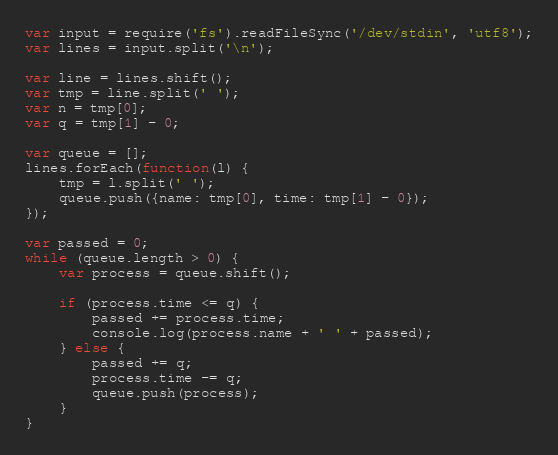<code> <loc_0><loc_0><loc_500><loc_500><_JavaScript_>var input = require('fs').readFileSync('/dev/stdin', 'utf8');
var lines = input.split('\n');

var line = lines.shift();
var tmp = line.split(' ');
var n = tmp[0];
var q = tmp[1] - 0;

var queue = [];
lines.forEach(function(l) {
	tmp = l.split(' ');
	queue.push({name: tmp[0], time: tmp[1] - 0});
});

var passed = 0;
while (queue.length > 0) {
	var process = queue.shift();

	if (process.time <= q) {
		passed += process.time;
		console.log(process.name + ' ' + passed);
	} else {
		passed += q;
		process.time -= q;
		queue.push(process);
	}
}</code> 